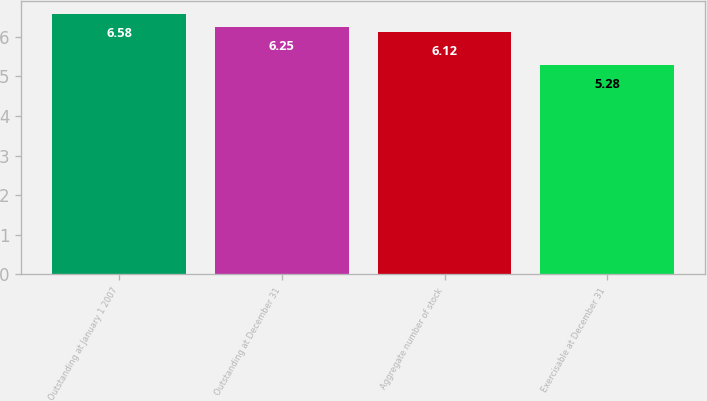Convert chart to OTSL. <chart><loc_0><loc_0><loc_500><loc_500><bar_chart><fcel>Outstanding at January 1 2007<fcel>Outstanding at December 31<fcel>Aggregate number of stock<fcel>Exercisable at December 31<nl><fcel>6.58<fcel>6.25<fcel>6.12<fcel>5.28<nl></chart> 